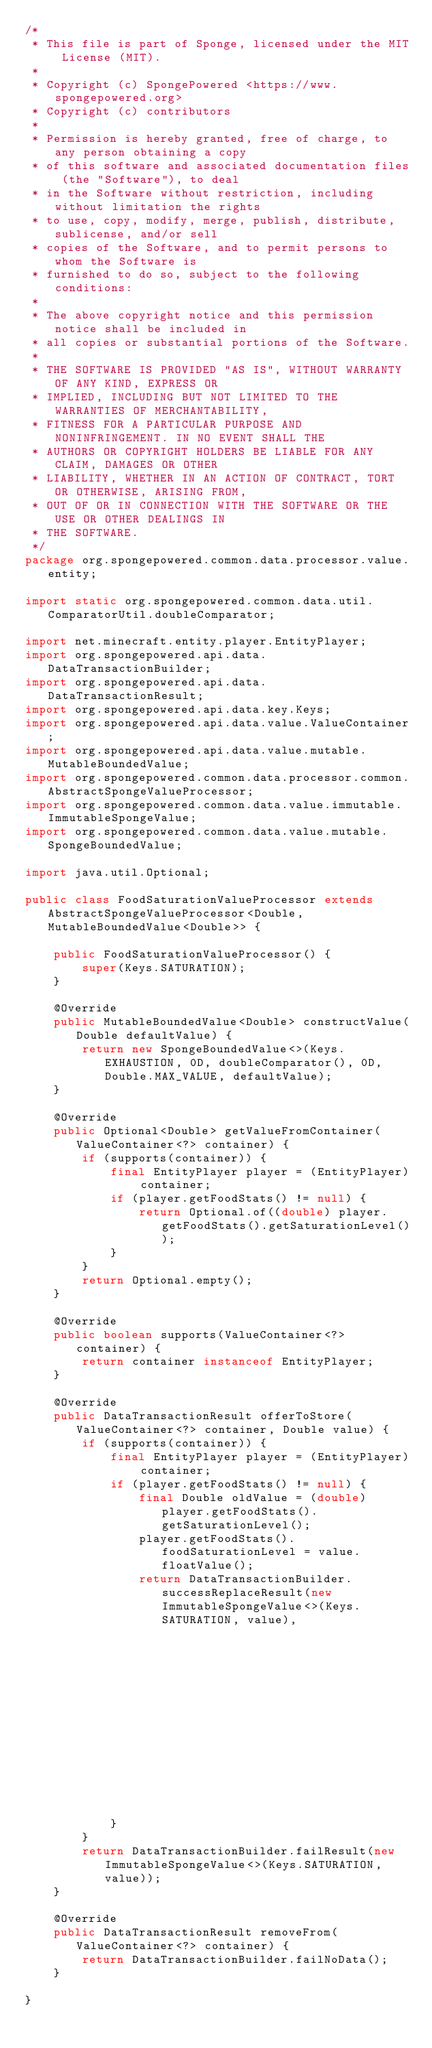Convert code to text. <code><loc_0><loc_0><loc_500><loc_500><_Java_>/*
 * This file is part of Sponge, licensed under the MIT License (MIT).
 *
 * Copyright (c) SpongePowered <https://www.spongepowered.org>
 * Copyright (c) contributors
 *
 * Permission is hereby granted, free of charge, to any person obtaining a copy
 * of this software and associated documentation files (the "Software"), to deal
 * in the Software without restriction, including without limitation the rights
 * to use, copy, modify, merge, publish, distribute, sublicense, and/or sell
 * copies of the Software, and to permit persons to whom the Software is
 * furnished to do so, subject to the following conditions:
 *
 * The above copyright notice and this permission notice shall be included in
 * all copies or substantial portions of the Software.
 *
 * THE SOFTWARE IS PROVIDED "AS IS", WITHOUT WARRANTY OF ANY KIND, EXPRESS OR
 * IMPLIED, INCLUDING BUT NOT LIMITED TO THE WARRANTIES OF MERCHANTABILITY,
 * FITNESS FOR A PARTICULAR PURPOSE AND NONINFRINGEMENT. IN NO EVENT SHALL THE
 * AUTHORS OR COPYRIGHT HOLDERS BE LIABLE FOR ANY CLAIM, DAMAGES OR OTHER
 * LIABILITY, WHETHER IN AN ACTION OF CONTRACT, TORT OR OTHERWISE, ARISING FROM,
 * OUT OF OR IN CONNECTION WITH THE SOFTWARE OR THE USE OR OTHER DEALINGS IN
 * THE SOFTWARE.
 */
package org.spongepowered.common.data.processor.value.entity;

import static org.spongepowered.common.data.util.ComparatorUtil.doubleComparator;

import net.minecraft.entity.player.EntityPlayer;
import org.spongepowered.api.data.DataTransactionBuilder;
import org.spongepowered.api.data.DataTransactionResult;
import org.spongepowered.api.data.key.Keys;
import org.spongepowered.api.data.value.ValueContainer;
import org.spongepowered.api.data.value.mutable.MutableBoundedValue;
import org.spongepowered.common.data.processor.common.AbstractSpongeValueProcessor;
import org.spongepowered.common.data.value.immutable.ImmutableSpongeValue;
import org.spongepowered.common.data.value.mutable.SpongeBoundedValue;

import java.util.Optional;

public class FoodSaturationValueProcessor extends AbstractSpongeValueProcessor<Double, MutableBoundedValue<Double>> {

    public FoodSaturationValueProcessor() {
        super(Keys.SATURATION);
    }

    @Override
    public MutableBoundedValue<Double> constructValue(Double defaultValue) {
        return new SpongeBoundedValue<>(Keys.EXHAUSTION, 0D, doubleComparator(), 0D, Double.MAX_VALUE, defaultValue);
    }

    @Override
    public Optional<Double> getValueFromContainer(ValueContainer<?> container) {
        if (supports(container)) {
            final EntityPlayer player = (EntityPlayer) container;
            if (player.getFoodStats() != null) {
                return Optional.of((double) player.getFoodStats().getSaturationLevel());
            }
        }
        return Optional.empty();
    }

    @Override
    public boolean supports(ValueContainer<?> container) {
        return container instanceof EntityPlayer;
    }

    @Override
    public DataTransactionResult offerToStore(ValueContainer<?> container, Double value) {
        if (supports(container)) {
            final EntityPlayer player = (EntityPlayer) container;
            if (player.getFoodStats() != null) {
                final Double oldValue = (double) player.getFoodStats().getSaturationLevel();
                player.getFoodStats().foodSaturationLevel = value.floatValue();
                return DataTransactionBuilder.successReplaceResult(new ImmutableSpongeValue<>(Keys.SATURATION, value),
                                                                   new ImmutableSpongeValue<>(Keys.SATURATION, oldValue));
            }
        }
        return DataTransactionBuilder.failResult(new ImmutableSpongeValue<>(Keys.SATURATION, value));
    }

    @Override
    public DataTransactionResult removeFrom(ValueContainer<?> container) {
        return DataTransactionBuilder.failNoData();
    }

}
</code> 